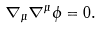Convert formula to latex. <formula><loc_0><loc_0><loc_500><loc_500>\nabla _ { \mu } \nabla ^ { \mu } \phi = 0 .</formula> 